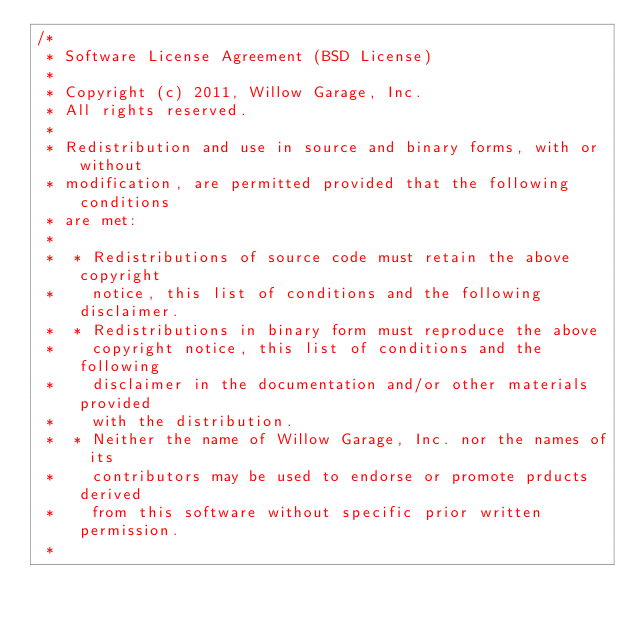Convert code to text. <code><loc_0><loc_0><loc_500><loc_500><_C++_>/* 
 * Software License Agreement (BSD License)
 *
 * Copyright (c) 2011, Willow Garage, Inc.
 * All rights reserved.
 *
 * Redistribution and use in source and binary forms, with or without
 * modification, are permitted provided that the following conditions
 * are met:
 *
 *  * Redistributions of source code must retain the above copyright
 *    notice, this list of conditions and the following disclaimer.
 *  * Redistributions in binary form must reproduce the above
 *    copyright notice, this list of conditions and the following
 *    disclaimer in the documentation and/or other materials provided
 *    with the distribution.
 *  * Neither the name of Willow Garage, Inc. nor the names of its
 *    contributors may be used to endorse or promote prducts derived
 *    from this software without specific prior written permission.
 *</code> 